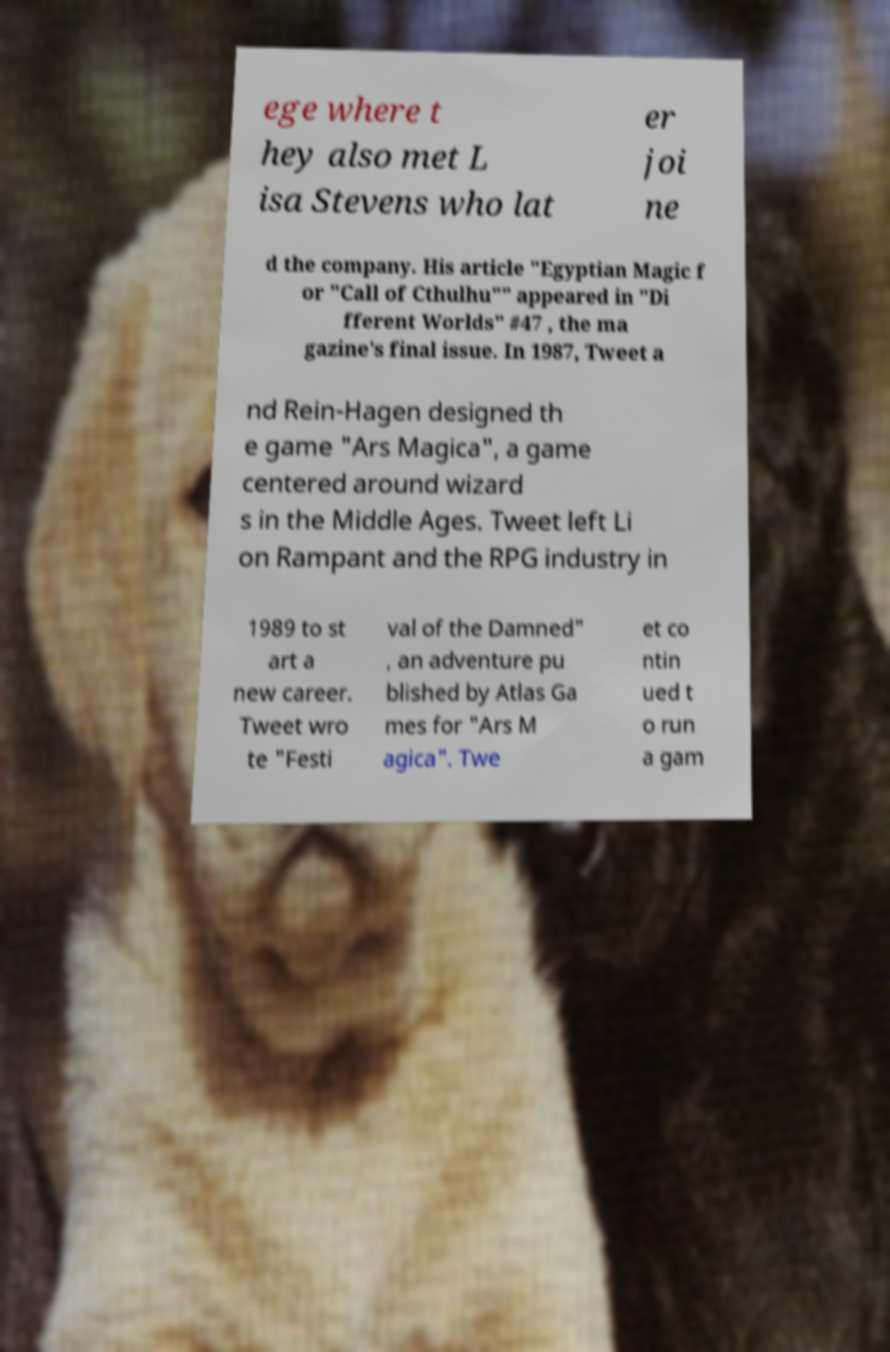Please identify and transcribe the text found in this image. ege where t hey also met L isa Stevens who lat er joi ne d the company. His article "Egyptian Magic f or "Call of Cthulhu"" appeared in "Di fferent Worlds" #47 , the ma gazine's final issue. In 1987, Tweet a nd Rein-Hagen designed th e game "Ars Magica", a game centered around wizard s in the Middle Ages. Tweet left Li on Rampant and the RPG industry in 1989 to st art a new career. Tweet wro te "Festi val of the Damned" , an adventure pu blished by Atlas Ga mes for "Ars M agica". Twe et co ntin ued t o run a gam 